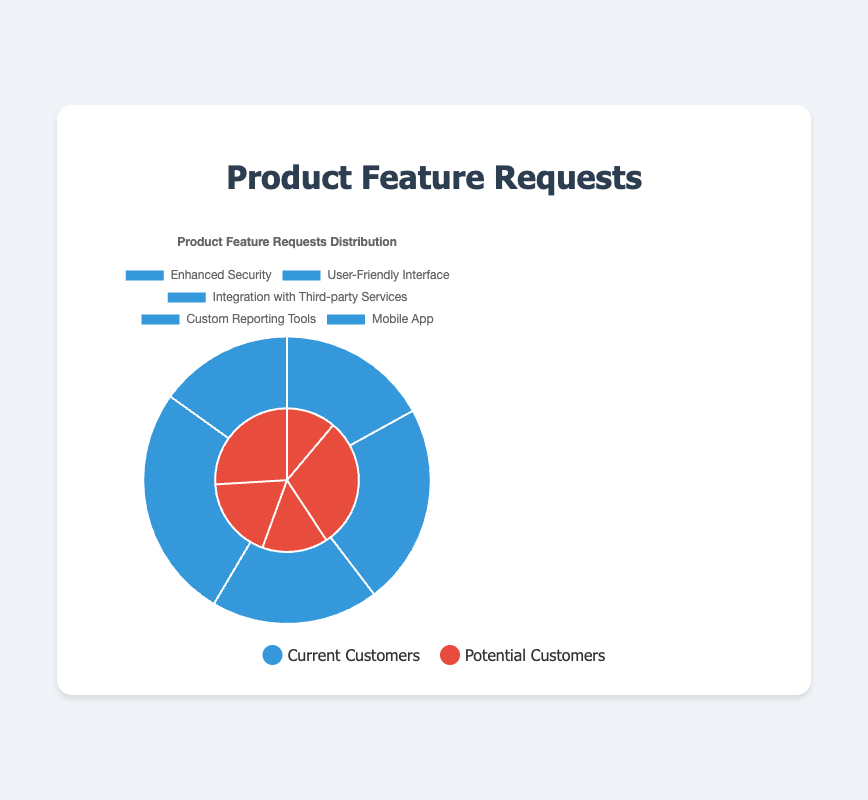What's the most requested feature by potential customers? To find the most requested feature by potential customers, we look at the red segments of the pie chart and identify "User-Friendly Interface" with an 80% preference.
Answer: User-Friendly Interface Which customer group has more requests for "Mobile App"? Compare the blue and red segments for "Mobile App". Blue (current customers) has 40, red (potential customers) has 70. Since red is larger, potential customers have more requests.
Answer: Potential Customers What is the total number of feature requests for the "Enhanced Security" feature? Add the requests from both groups for "Enhanced Security": current customers (45) and potential customers (30). 45 + 30 = 75.
Answer: 75 Which group has more total feature requests overall? Sum the requests for each group: 
- Current: 45 + 60 + 50 + 70 + 40 = 265 
- Potential: 30 + 80 + 40 + 50 + 70 = 270 
Potential customers have more requests.
Answer: Potential Customers What percentage of requests for the "Custom Reporting Tools" feature comes from current customers? Calculate the percentage: (requests by current customers for the feature / total requests for the feature) * 100. That is (70 / (70 + 50)) * 100 = 58.33%.
Answer: 58.33% Which feature shows a preference for the same number of requests among both groups? Look for features where the segments in blue and red are equally sized. There is no such feature where the number of requests is exactly the same.
Answer: None How many more requests are there for the "User-Friendly Interface" from potential customers compared to current customers? Subtract the requests from current customers from those of potential customers for "User-Friendly Interface": 80 - 60 = 20.
Answer: 20 Which feature has the most balanced request distribution? Evaluate the ratios of requests between current and potential customers for all features. The closer the ratio to 1, the more balanced the distribution. "Integration with Third-party Services" has the smallest difference with a ratio of 50 (current) to 40 (potential), equating to 1.25.
Answer: Integration with Third-party Services 